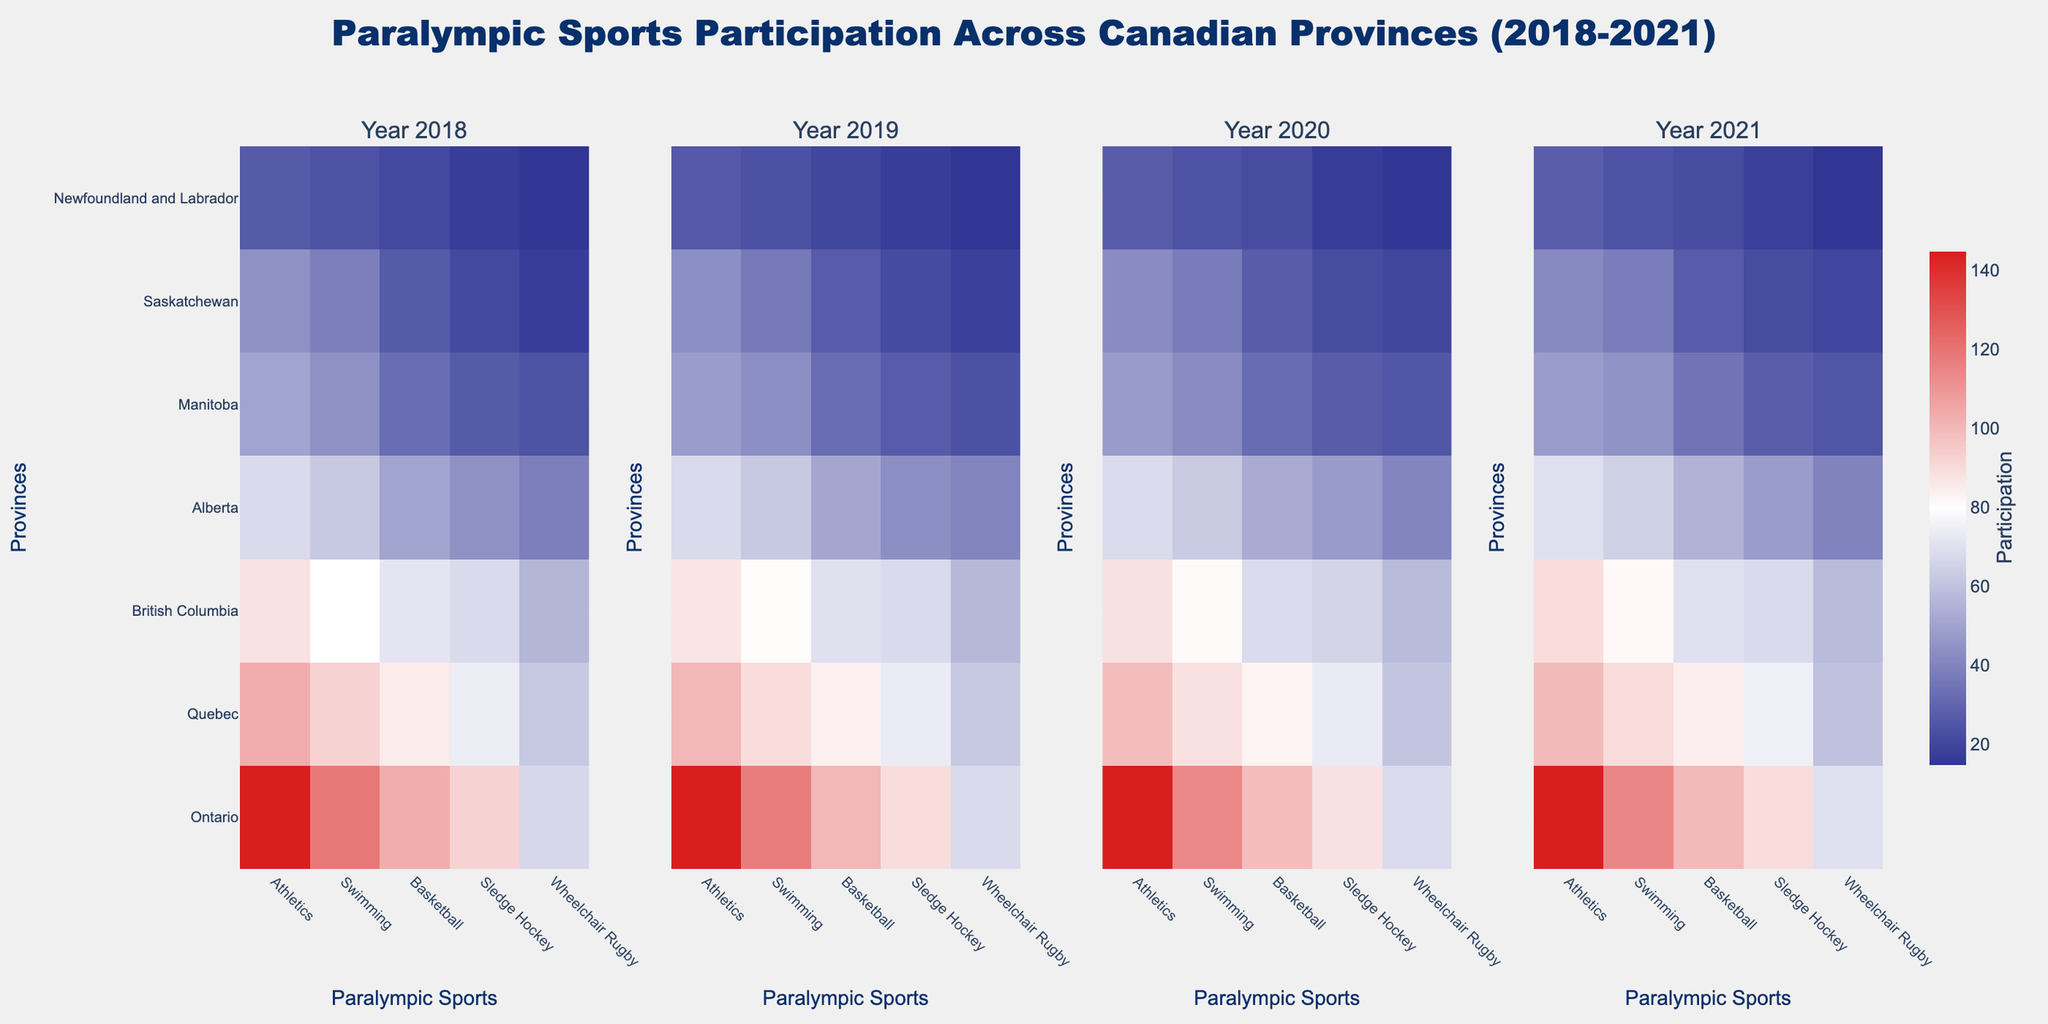What's the range of athletic participation in Ontario across the years? To find the range, we identify the minimum and maximum values of athletic participation in Ontario from the data: 120 in 2018 and 145 in 2021. The range is calculated as the maximum value minus the minimum value, which is 145 - 120 = 25.
Answer: 25 Which province had the highest participation in Sledge Hockey in 2020? To determine the province with the highest participation, we look at the Sledge Hockey column for the year 2020 across all provinces. Ontario has the highest value of 85.
Answer: Ontario How did participation in Wheelchair Rugby in Quebec change from 2019 to 2020? To find the change, subtract the 2019 value from the 2020 value for Wheelchair Rugby in Quebec. The values are 55 in 2019 and 58 in 2020. The change is 58 - 55 = 3.
Answer: Increased by 3 Which sport showed the most consistent participation levels across all provinces in 2021? To determine this, we compare the values in the year 2021 for each sport across all provinces. Calculate the variance or observe the spread visually. Swimming seems to have more uniform values across provinces in 2021.
Answer: Swimming Compare the total participation for Athletics in 2018 and 2021. Which year had a higher total and by how much? To compare, sum the values for Athletics across all provinces for 2018 and 2021. For 2018: 120 + 85 + 72 + 55 + 40 + 35 + 20 = 427. For 2021: 145 + 100 + 90 + 70 + 48 + 42 + 28 = 523. The difference is 523 - 427 = 96, so 2021 had a higher total by 96.
Answer: 2021 by 96 Which sport had the highest increase in participation in Alberta from 2018 to 2021? To find this, calculate the difference for each sport between 2018 and 2021 in Alberta. Athletics increased from 55 to 70 (+15), Swimming from 50 to 65 (+15), Basketball from 40 to 55 (+15), Sledge Hockey from 35 to 48 (+13), and Wheelchair Rugby from 30 to 40 (+10). Athletics, Swimming, and Basketball each increased by 15.
Answer: Athletics, Swimming, Basketball (tie) What is the average participation in Basketball for British Columbia across all years? To find the average, sum the Basketball values for British Columbia from 2018 to 2021 and divide by the number of years: (58 + 62 + 65 + 70) / 4 = 63.75.
Answer: 63.75 